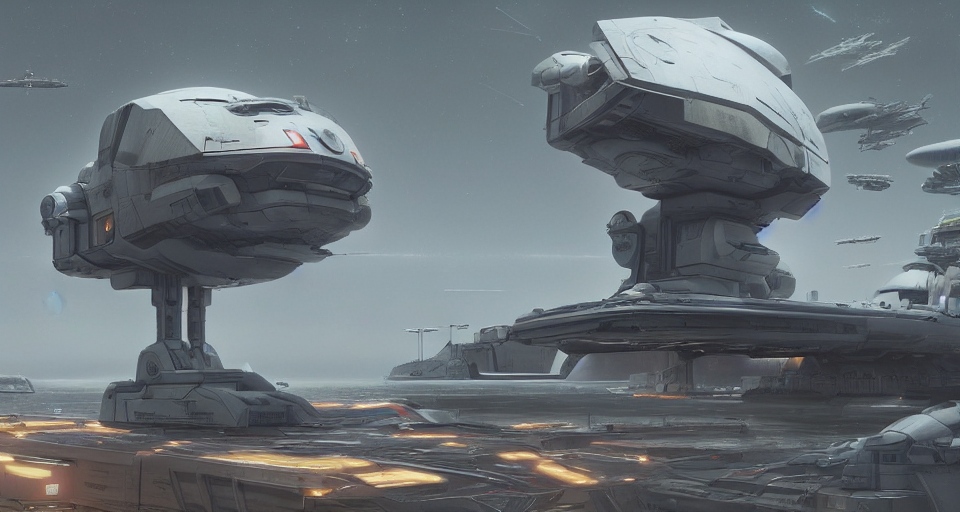Is the image blurry?
A. No
B. Yes
Answer with the option's letter from the given choices directly.
 A. 